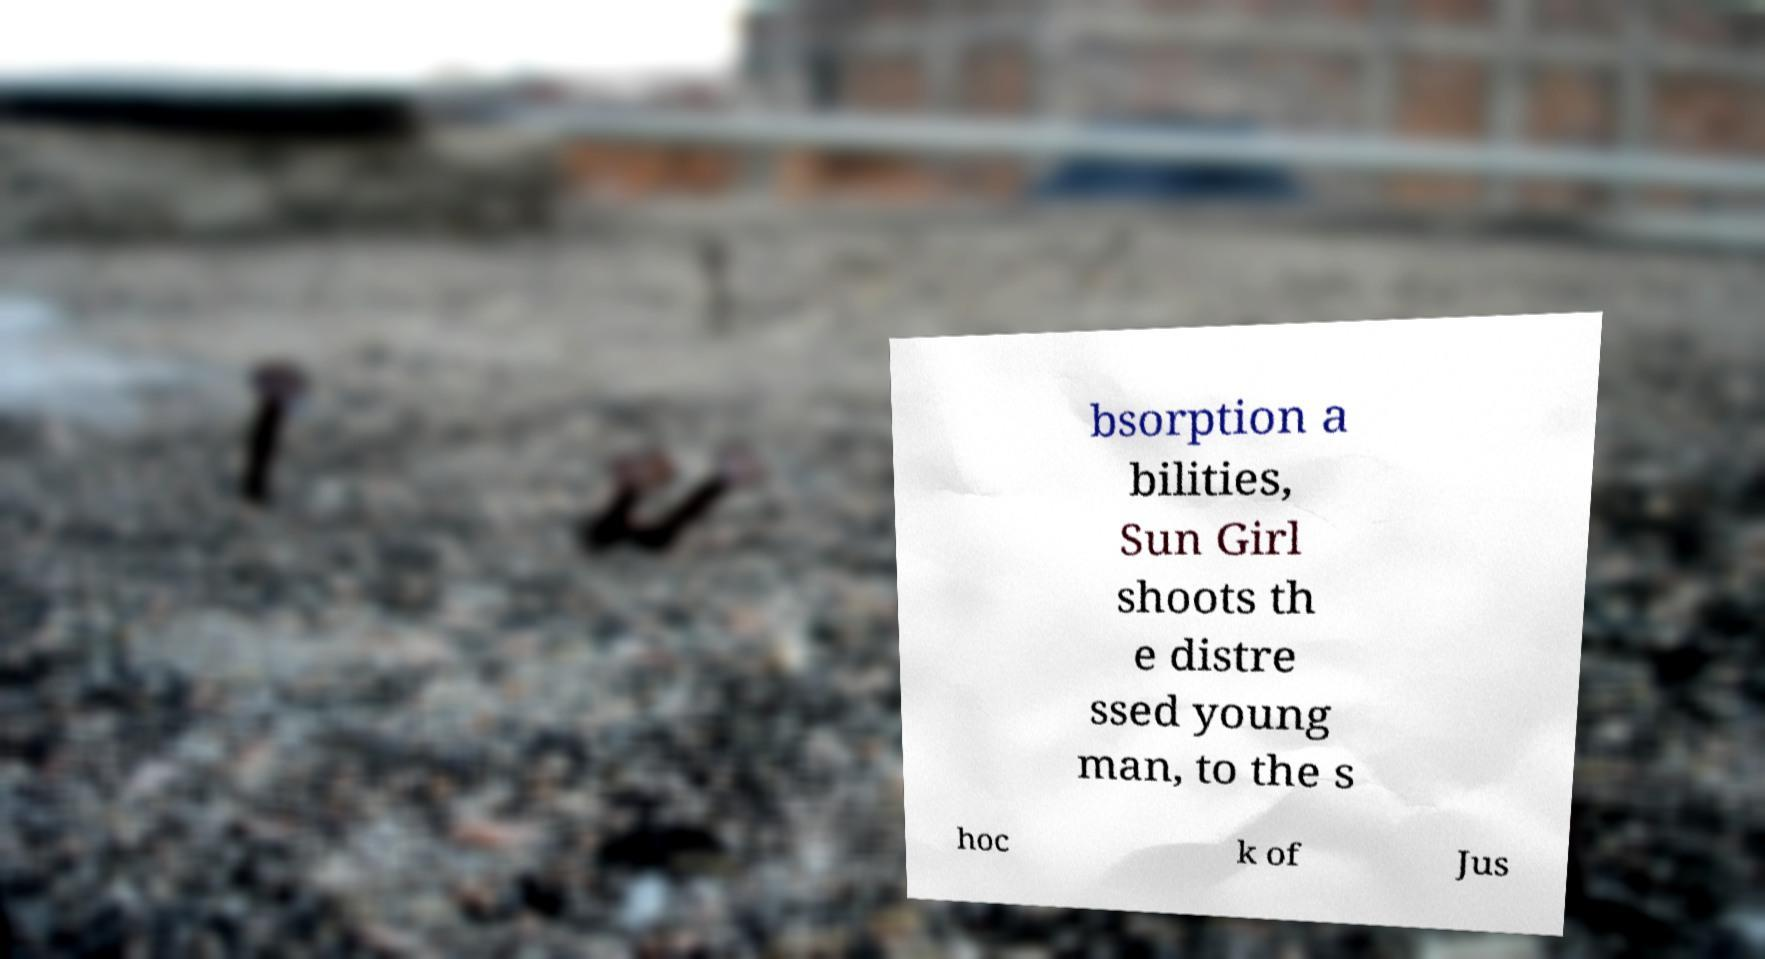Can you read and provide the text displayed in the image?This photo seems to have some interesting text. Can you extract and type it out for me? bsorption a bilities, Sun Girl shoots th e distre ssed young man, to the s hoc k of Jus 